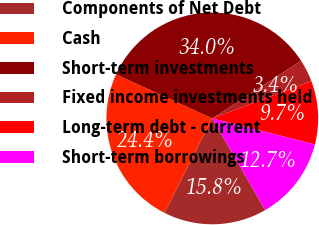<chart> <loc_0><loc_0><loc_500><loc_500><pie_chart><fcel>Components of Net Debt<fcel>Cash<fcel>Short-term investments<fcel>Fixed income investments held<fcel>Long-term debt - current<fcel>Short-term borrowings<nl><fcel>15.79%<fcel>24.35%<fcel>34.01%<fcel>3.44%<fcel>9.68%<fcel>12.73%<nl></chart> 